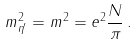Convert formula to latex. <formula><loc_0><loc_0><loc_500><loc_500>m ^ { 2 } _ { \eta ^ { \prime } } = m ^ { 2 } = e ^ { 2 } \frac { N } { \pi } \, .</formula> 